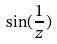Convert formula to latex. <formula><loc_0><loc_0><loc_500><loc_500>\sin ( \frac { 1 } { z } )</formula> 